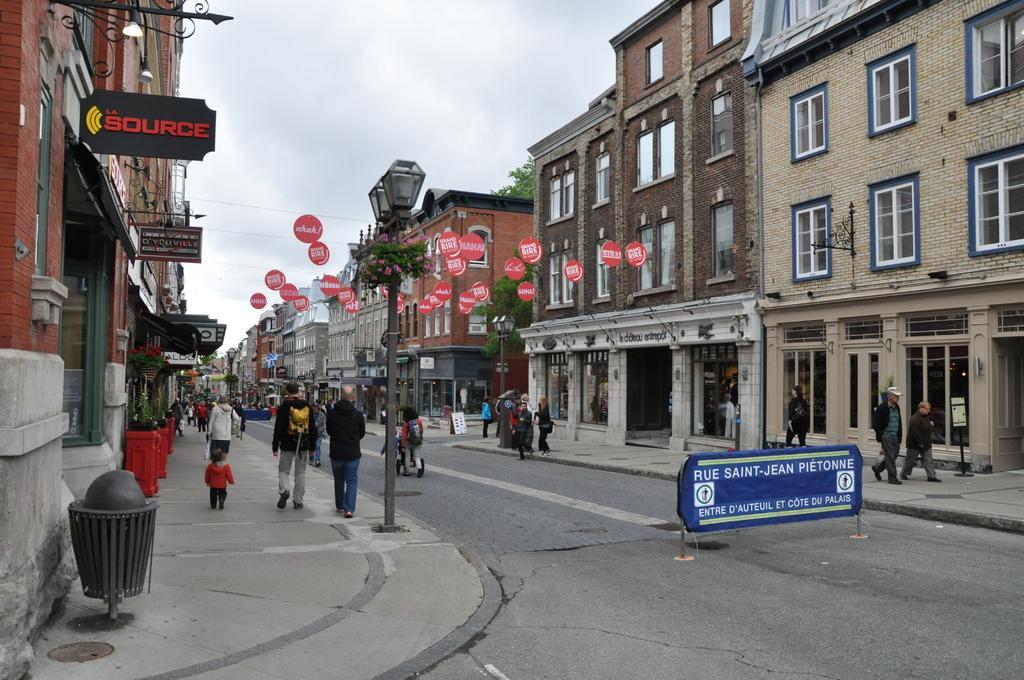Describe this image in one or two sentences. In this image there are buildings, boards, trees, people, plants, light poles, road and objects. Something is written on the boards. In the background of the image there is a cloudy sky. Among them few people are walking and few people wore bags. 